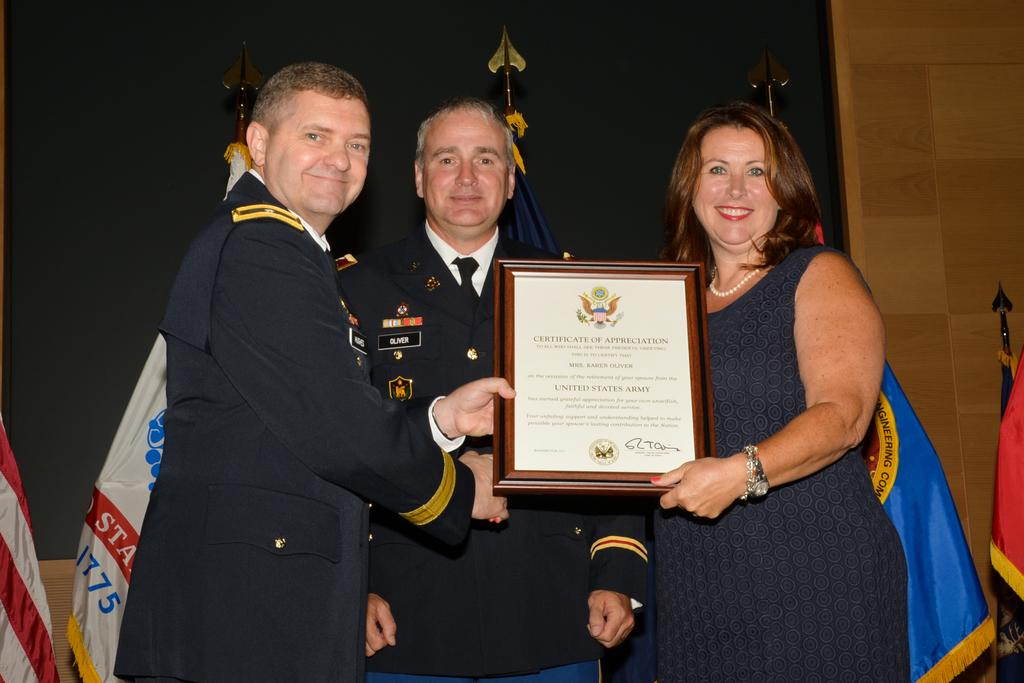How many people are in the image? There are three persons standing in the image. What are the expressions on their faces? The persons are smiling. What are two of the persons holding? They are holding a certificate. What can be seen in the image besides the people? There are flags, poles, and a wall in the background. What type of fruit is hanging from the poles in the image? There is no fruit hanging from the poles in the image. What record is being broken by the persons in the image? There is no indication in the image that a record is being broken. 